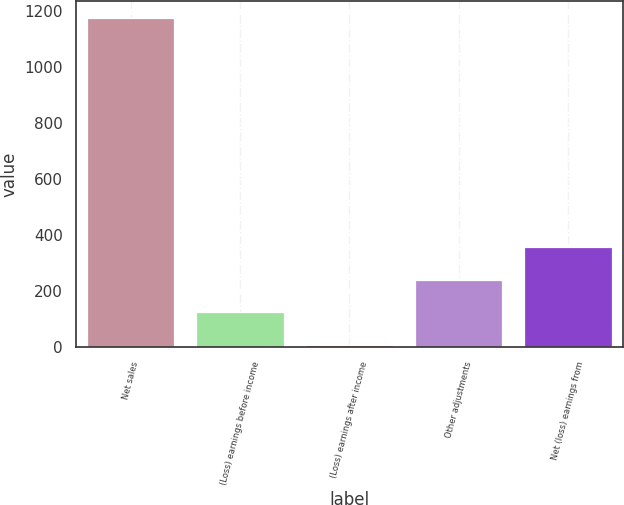<chart> <loc_0><loc_0><loc_500><loc_500><bar_chart><fcel>Net sales<fcel>(Loss) earnings before income<fcel>(Loss) earnings after income<fcel>Other adjustments<fcel>Net (loss) earnings from<nl><fcel>1177<fcel>124<fcel>7<fcel>241<fcel>358<nl></chart> 